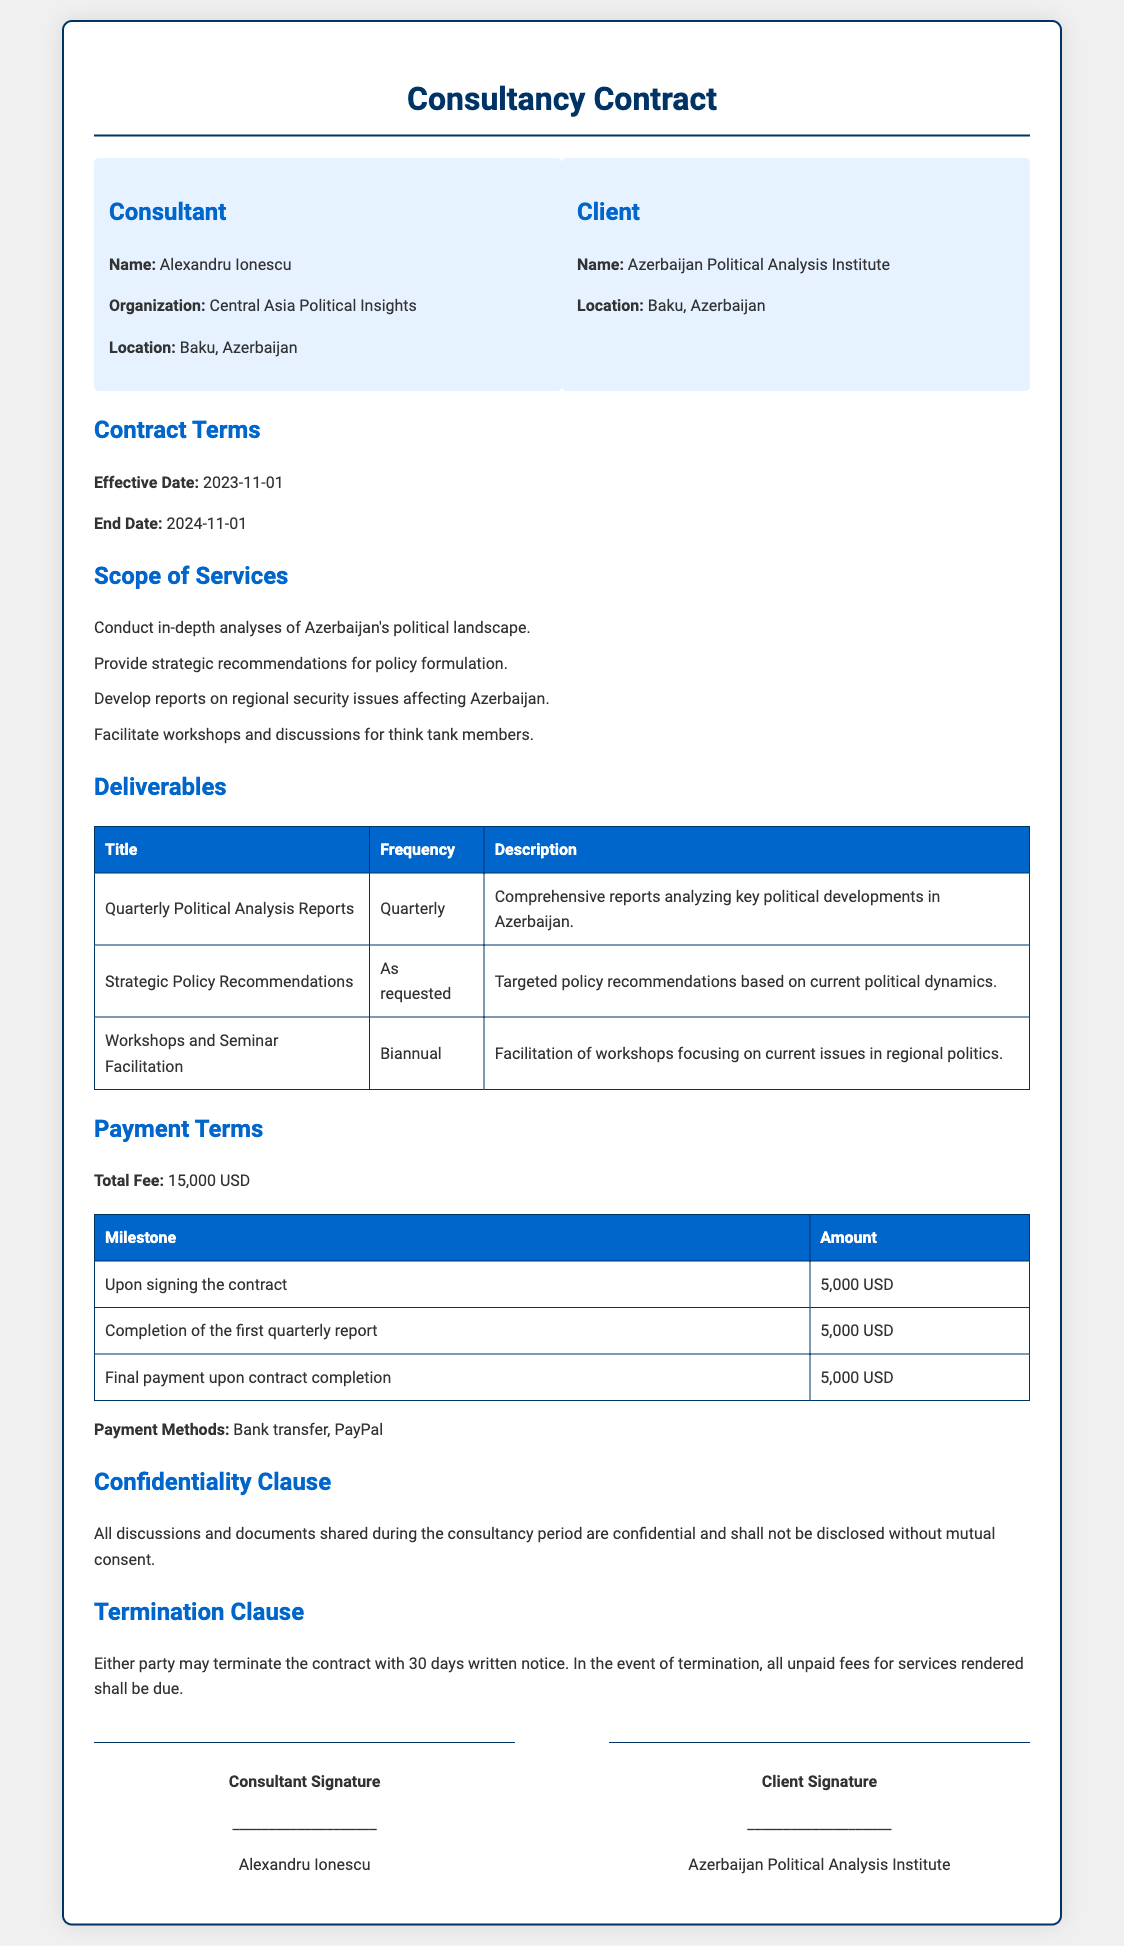what is the name of the consultant? The document specifies the name of the consultant as "Alexandru Ionescu."
Answer: Alexandru Ionescu what is the total fee for the consultancy services? The total fee mentioned in the document for the consultancy services is "15,000 USD."
Answer: 15,000 USD when is the effective date of the contract? The effective date of the contract is stated as "2023-11-01."
Answer: 2023-11-01 how often are the quarterly political analysis reports delivered? The frequency of the quarterly political analysis reports is mentioned as "Quarterly."
Answer: Quarterly what is the amount due upon signing the contract? The document states the amount due upon signing the contract as "5,000 USD."
Answer: 5,000 USD which organization is the client? The client organization identified in the document is the "Azerbaijan Political Analysis Institute."
Answer: Azerbaijan Political Analysis Institute how many workshops are facilitated according to the scope of services? The document states that workshops are facilitated "Biannual," indicating twice a year.
Answer: Biannual what happens in the event of contract termination? The termination clause indicates that "all unpaid fees for services rendered shall be due" upon contract termination.
Answer: All unpaid fees for services rendered shall be due what payment methods are specified in the document? The document specifies that payments can be made via "Bank transfer, PayPal."
Answer: Bank transfer, PayPal 